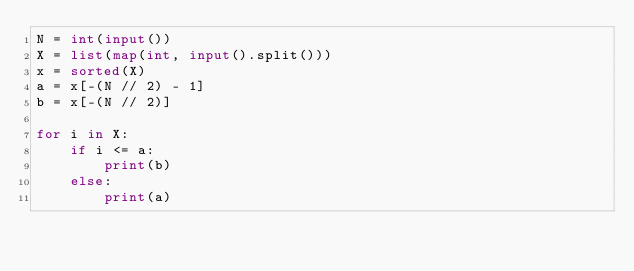<code> <loc_0><loc_0><loc_500><loc_500><_Python_>N = int(input())
X = list(map(int, input().split()))
x = sorted(X)
a = x[-(N // 2) - 1]
b = x[-(N // 2)]

for i in X:
    if i <= a:
        print(b)
    else:
        print(a)</code> 